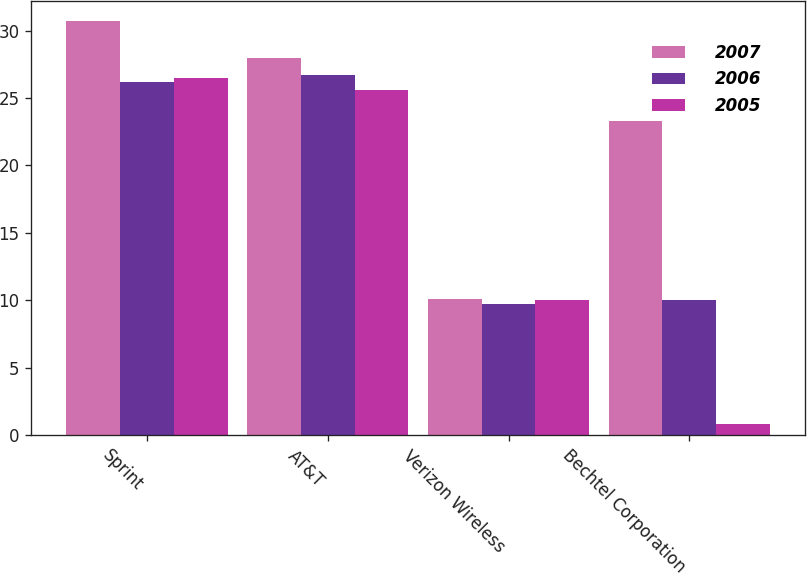Convert chart. <chart><loc_0><loc_0><loc_500><loc_500><stacked_bar_chart><ecel><fcel>Sprint<fcel>AT&T<fcel>Verizon Wireless<fcel>Bechtel Corporation<nl><fcel>2007<fcel>30.7<fcel>28<fcel>10.1<fcel>23.3<nl><fcel>2006<fcel>26.2<fcel>26.7<fcel>9.7<fcel>10<nl><fcel>2005<fcel>26.5<fcel>25.6<fcel>10<fcel>0.8<nl></chart> 